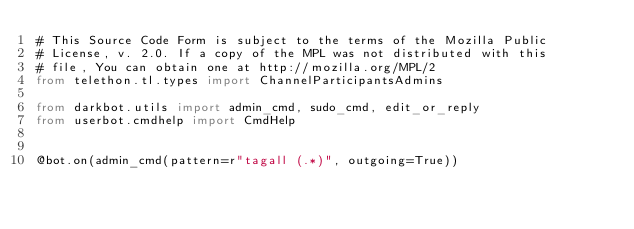<code> <loc_0><loc_0><loc_500><loc_500><_Python_># This Source Code Form is subject to the terms of the Mozilla Public
# License, v. 2.0. If a copy of the MPL was not distributed with this
# file, You can obtain one at http://mozilla.org/MPL/2
from telethon.tl.types import ChannelParticipantsAdmins

from darkbot.utils import admin_cmd, sudo_cmd, edit_or_reply
from userbot.cmdhelp import CmdHelp


@bot.on(admin_cmd(pattern=r"tagall (.*)", outgoing=True))</code> 